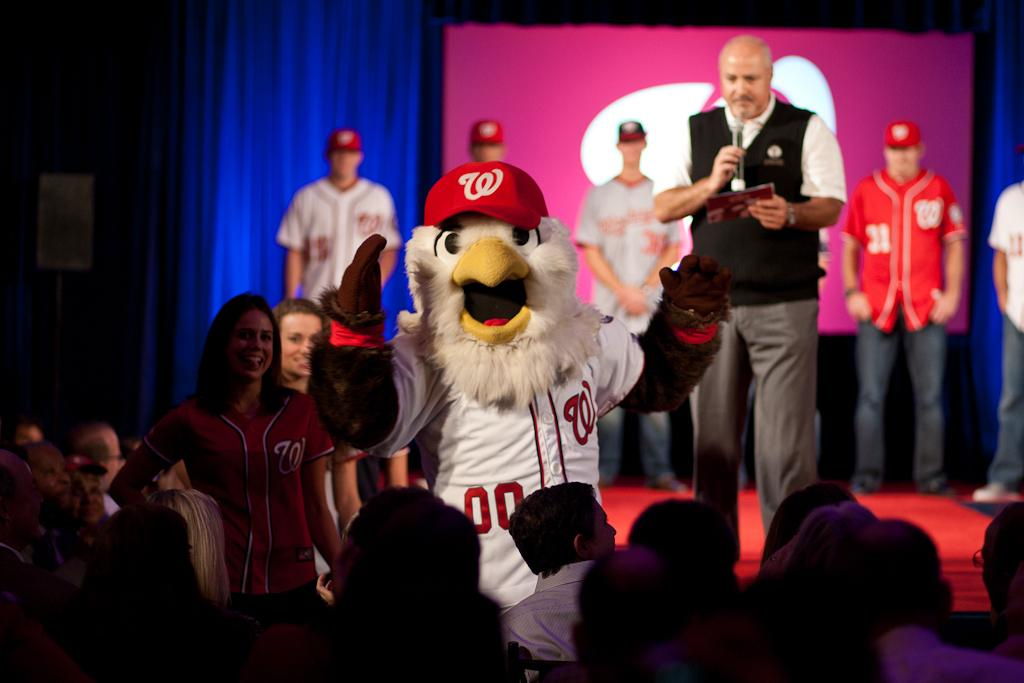How many people are in the image? There are people in the image, but the exact number is not specified. What can be seen in the background of the image? There is a curtain and a stage in the image. What is one person holding in the image? One person is holding a microphone in the image. What is another person holding in the image? Another person is holding a card in the image. Can you describe the costume worn by one of the people in the image? One person is wearing a costume in the image. What type of grip does the person holding the card have in the image? There is no information about the person's grip on the card in the image. What kind of jam is being served on the stage in the image? There is no jam or any food mentioned in the image; it features people, a curtain, a stage, a speaker, a costume, a microphone, and a card. 